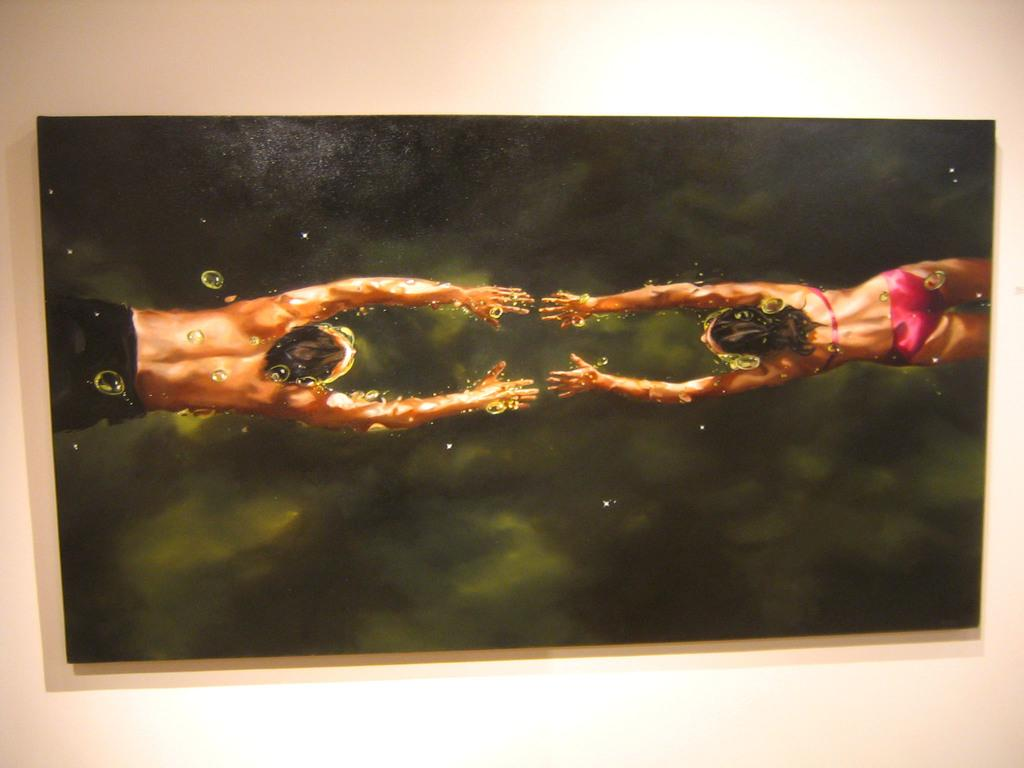What is the main subject of the image? The main subject of the image is a frame. What is depicted within the frame? The frame contains a painting of a woman and a man. What can be seen behind the frame in the image? There is a wall in the background of the image. How many holes can be seen in the painting of the woman and the man? There are no holes visible in the painting of the woman and the man; it is a flat, two-dimensional image. 